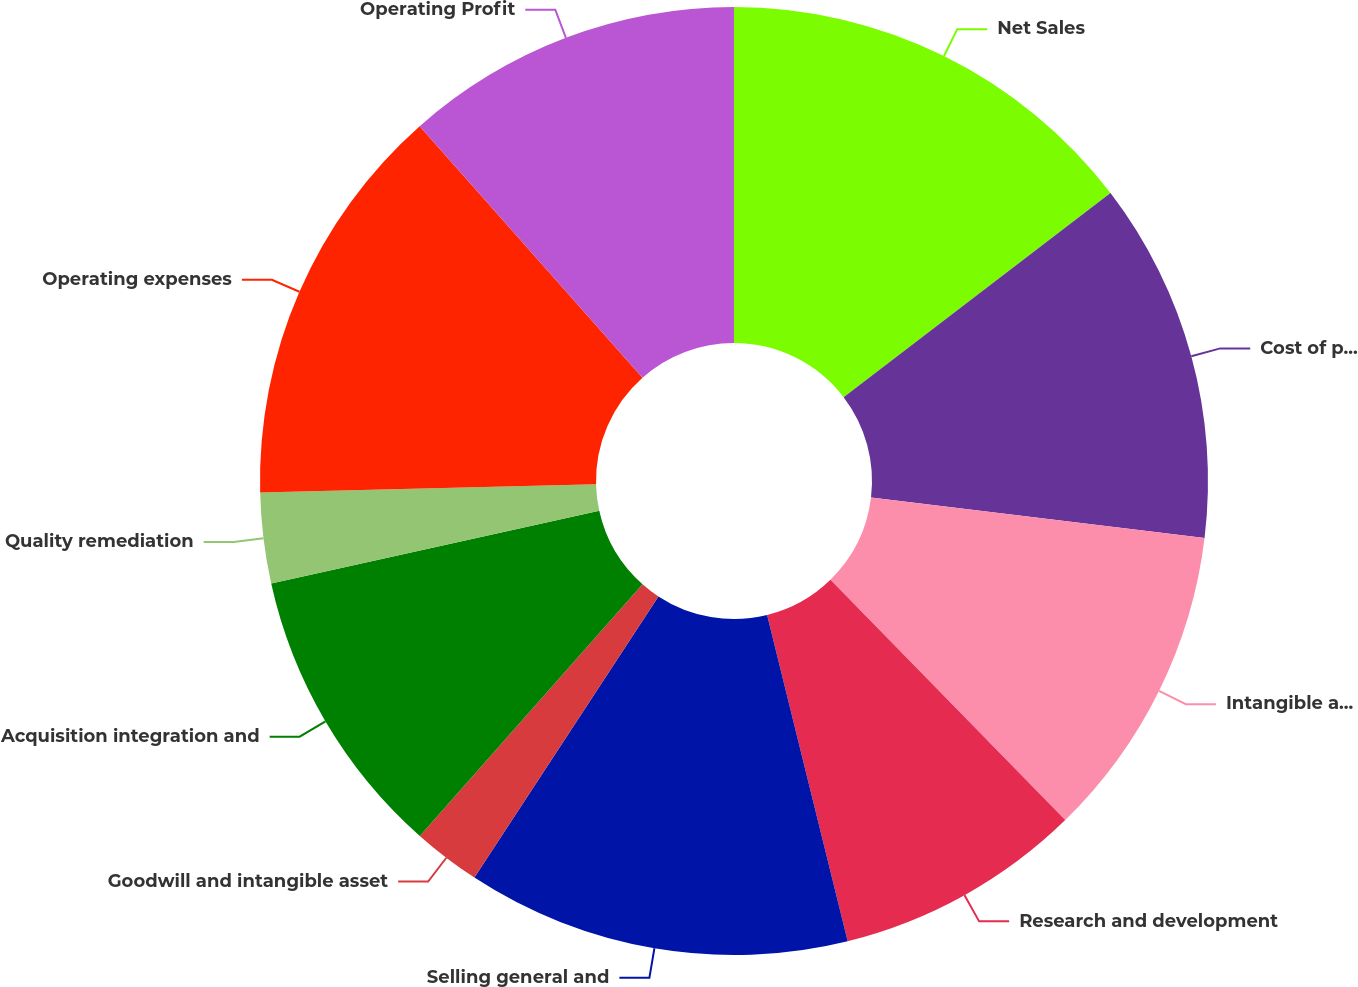Convert chart to OTSL. <chart><loc_0><loc_0><loc_500><loc_500><pie_chart><fcel>Net Sales<fcel>Cost of products sold<fcel>Intangible asset amortization<fcel>Research and development<fcel>Selling general and<fcel>Goodwill and intangible asset<fcel>Acquisition integration and<fcel>Quality remediation<fcel>Operating expenses<fcel>Operating Profit<nl><fcel>14.61%<fcel>12.31%<fcel>10.77%<fcel>8.46%<fcel>13.08%<fcel>2.31%<fcel>10.0%<fcel>3.08%<fcel>13.85%<fcel>11.54%<nl></chart> 